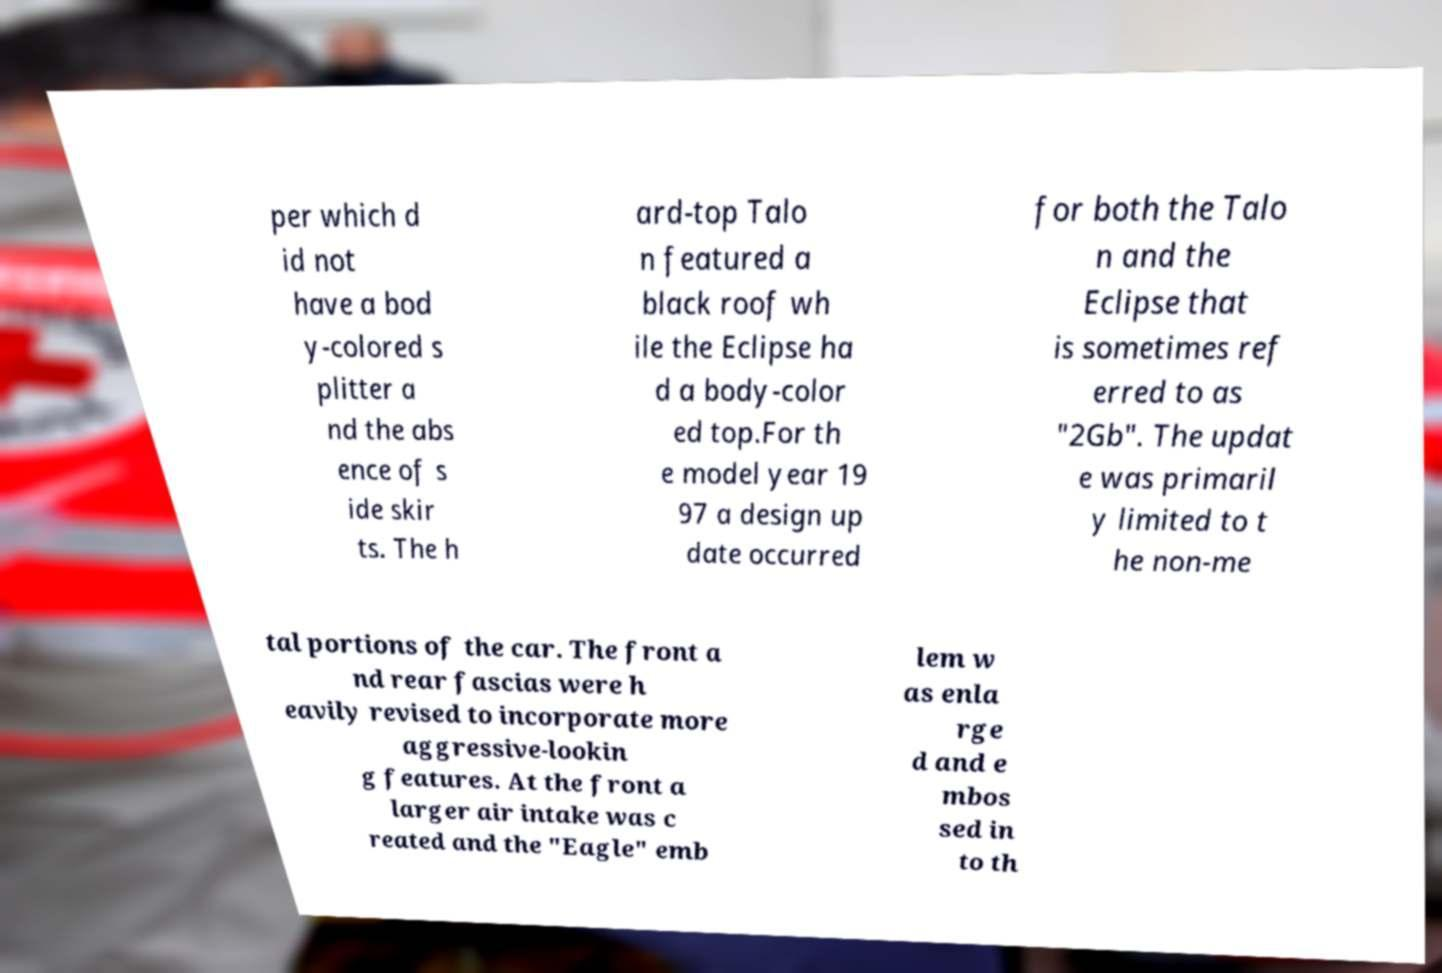Could you assist in decoding the text presented in this image and type it out clearly? per which d id not have a bod y-colored s plitter a nd the abs ence of s ide skir ts. The h ard-top Talo n featured a black roof wh ile the Eclipse ha d a body-color ed top.For th e model year 19 97 a design up date occurred for both the Talo n and the Eclipse that is sometimes ref erred to as "2Gb". The updat e was primaril y limited to t he non-me tal portions of the car. The front a nd rear fascias were h eavily revised to incorporate more aggressive-lookin g features. At the front a larger air intake was c reated and the "Eagle" emb lem w as enla rge d and e mbos sed in to th 